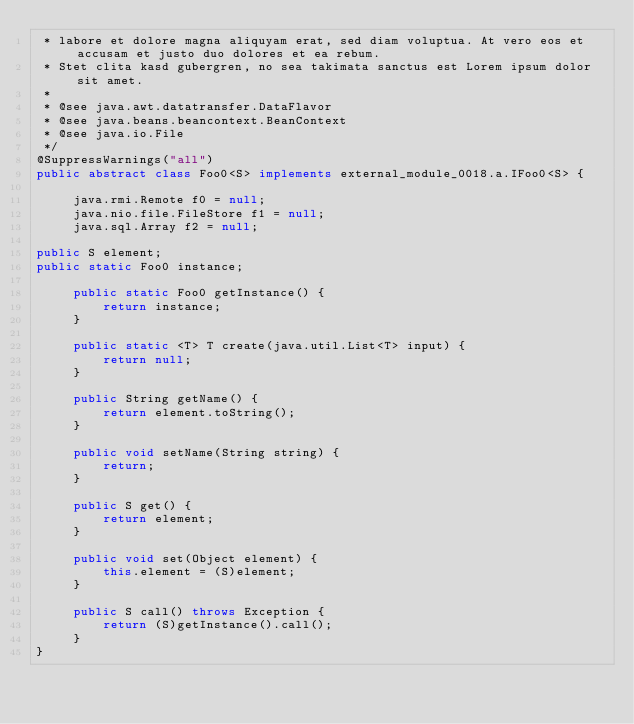<code> <loc_0><loc_0><loc_500><loc_500><_Java_> * labore et dolore magna aliquyam erat, sed diam voluptua. At vero eos et accusam et justo duo dolores et ea rebum. 
 * Stet clita kasd gubergren, no sea takimata sanctus est Lorem ipsum dolor sit amet. 
 *
 * @see java.awt.datatransfer.DataFlavor
 * @see java.beans.beancontext.BeanContext
 * @see java.io.File
 */
@SuppressWarnings("all")
public abstract class Foo0<S> implements external_module_0018.a.IFoo0<S> {

	 java.rmi.Remote f0 = null;
	 java.nio.file.FileStore f1 = null;
	 java.sql.Array f2 = null;

public S element;
public static Foo0 instance;

	 public static Foo0 getInstance() {
	 	 return instance;
	 }

	 public static <T> T create(java.util.List<T> input) {
	 	 return null;
	 }

	 public String getName() {
	 	 return element.toString();
	 }

	 public void setName(String string) {
	 	 return;
	 }

	 public S get() {
	 	 return element;
	 }

	 public void set(Object element) {
	 	 this.element = (S)element;
	 }

	 public S call() throws Exception {
	 	 return (S)getInstance().call();
	 }
}
</code> 